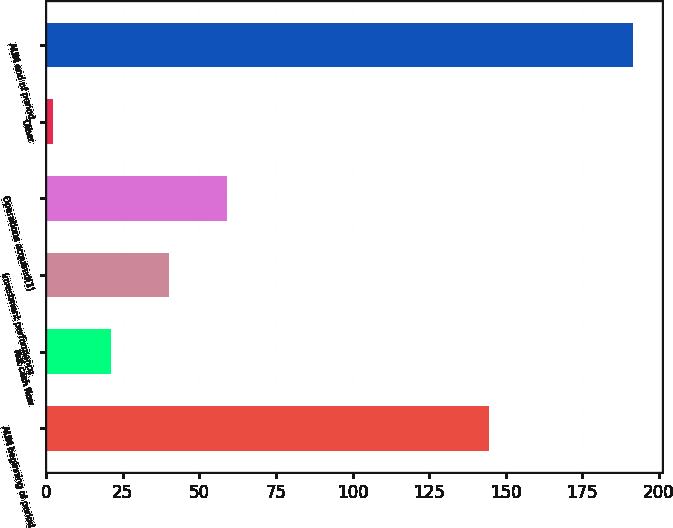Convert chart to OTSL. <chart><loc_0><loc_0><loc_500><loc_500><bar_chart><fcel>AUM beginning of period<fcel>Net cash flow<fcel>Investment performance<fcel>Operations acquired(1)<fcel>Other<fcel>AUM end of period<nl><fcel>144.5<fcel>21.12<fcel>40.04<fcel>58.96<fcel>2.2<fcel>191.4<nl></chart> 